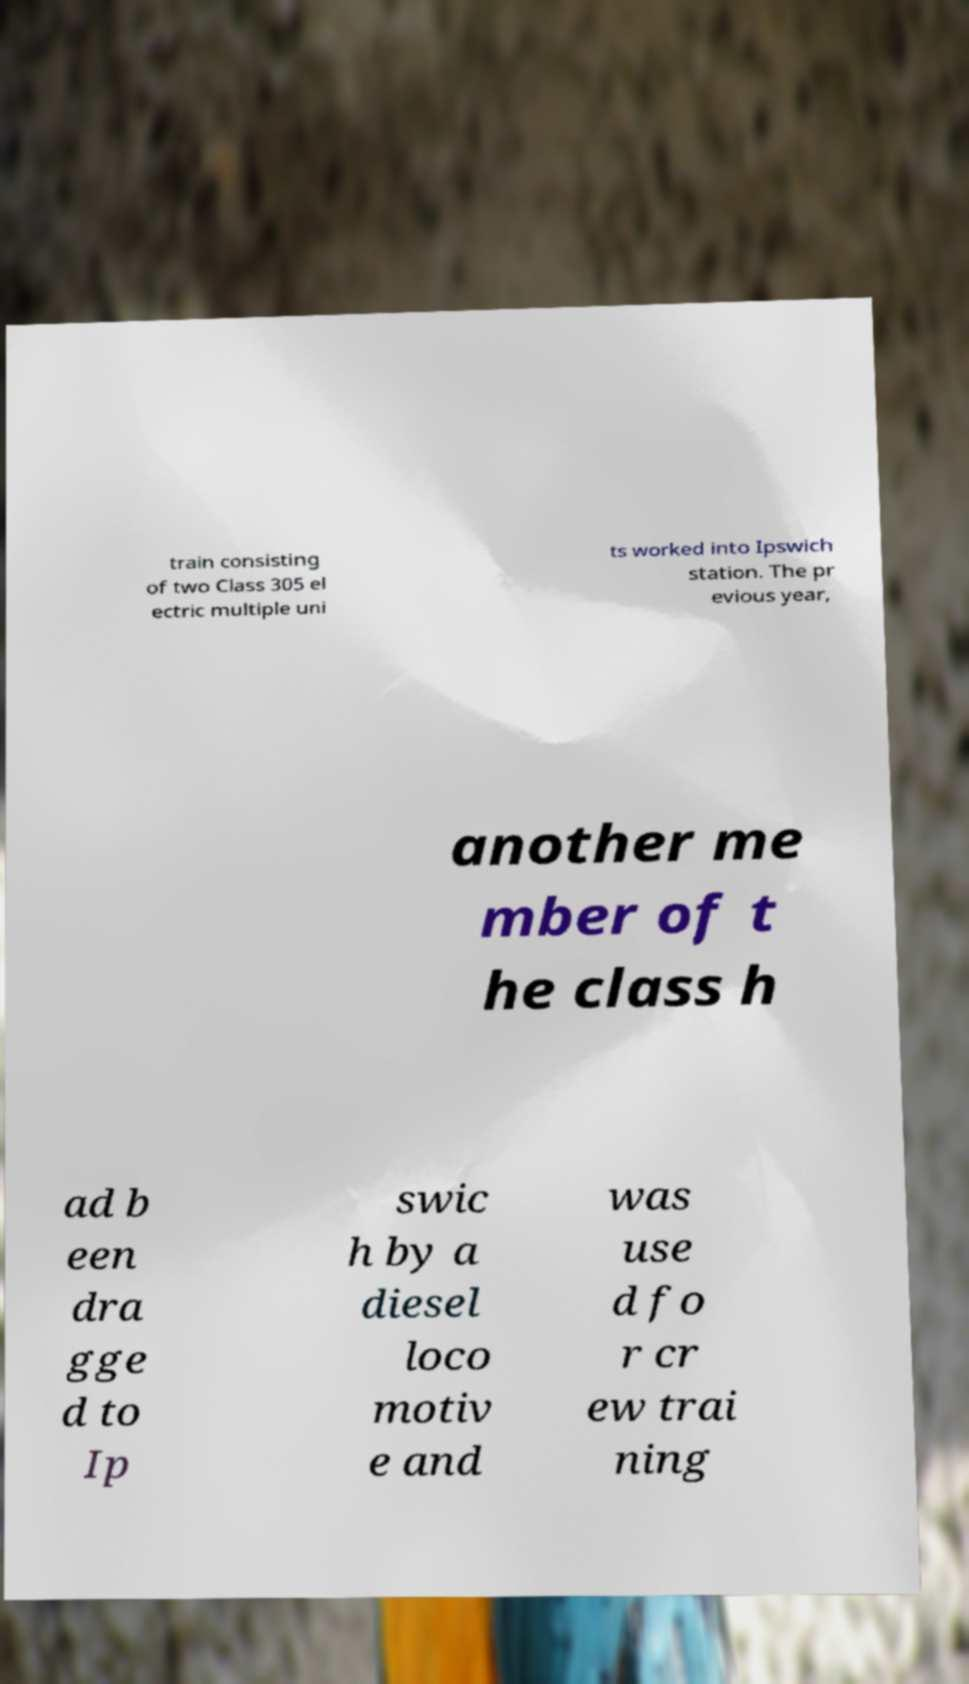There's text embedded in this image that I need extracted. Can you transcribe it verbatim? train consisting of two Class 305 el ectric multiple uni ts worked into Ipswich station. The pr evious year, another me mber of t he class h ad b een dra gge d to Ip swic h by a diesel loco motiv e and was use d fo r cr ew trai ning 